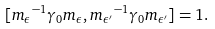<formula> <loc_0><loc_0><loc_500><loc_500>[ { m _ { \epsilon } } ^ { - 1 } \gamma _ { 0 } { m _ { \epsilon } } , { m _ { \epsilon ^ { \prime } } } ^ { - 1 } \gamma _ { 0 } { m _ { \epsilon ^ { \prime } } } ] = 1 .</formula> 